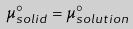<formula> <loc_0><loc_0><loc_500><loc_500>\mu _ { s o l i d } ^ { \circ } = \mu _ { s o l u t i o n } ^ { \circ }</formula> 